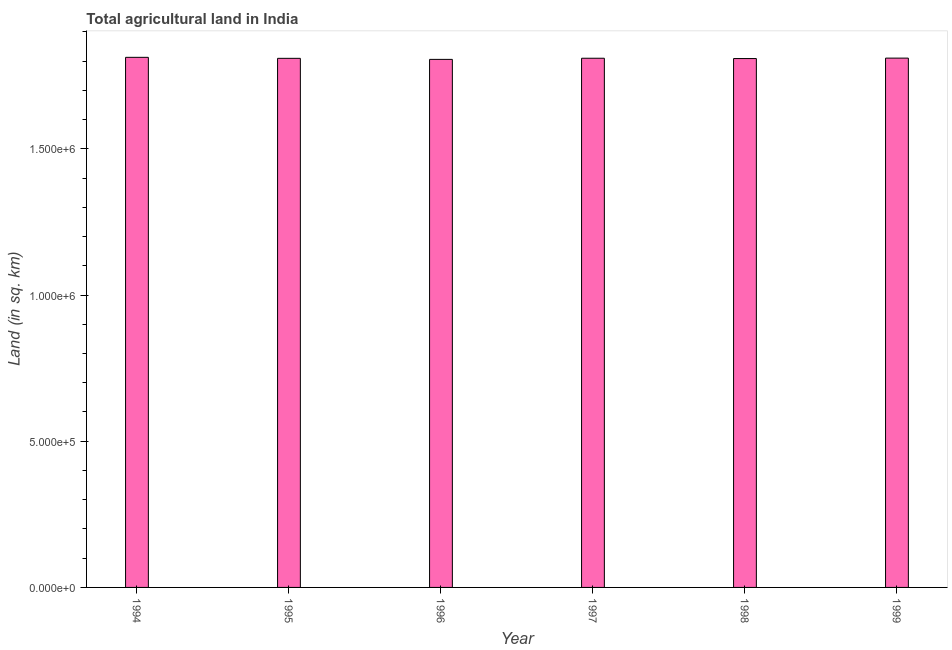Does the graph contain any zero values?
Your response must be concise. No. What is the title of the graph?
Provide a short and direct response. Total agricultural land in India. What is the label or title of the Y-axis?
Provide a succinct answer. Land (in sq. km). What is the agricultural land in 1998?
Provide a short and direct response. 1.81e+06. Across all years, what is the maximum agricultural land?
Your answer should be compact. 1.81e+06. Across all years, what is the minimum agricultural land?
Your answer should be compact. 1.81e+06. In which year was the agricultural land maximum?
Give a very brief answer. 1994. What is the sum of the agricultural land?
Your answer should be compact. 1.09e+07. What is the difference between the agricultural land in 1996 and 1999?
Provide a succinct answer. -4320. What is the average agricultural land per year?
Your answer should be very brief. 1.81e+06. What is the median agricultural land?
Offer a very short reply. 1.81e+06. In how many years, is the agricultural land greater than 400000 sq. km?
Provide a short and direct response. 6. What is the ratio of the agricultural land in 1997 to that in 1999?
Your answer should be very brief. 1. What is the difference between the highest and the second highest agricultural land?
Provide a succinct answer. 2700. What is the difference between the highest and the lowest agricultural land?
Provide a short and direct response. 7020. In how many years, is the agricultural land greater than the average agricultural land taken over all years?
Ensure brevity in your answer.  3. How many bars are there?
Offer a very short reply. 6. Are all the bars in the graph horizontal?
Provide a succinct answer. No. How many years are there in the graph?
Your response must be concise. 6. What is the difference between two consecutive major ticks on the Y-axis?
Offer a very short reply. 5.00e+05. What is the Land (in sq. km) in 1994?
Make the answer very short. 1.81e+06. What is the Land (in sq. km) in 1995?
Ensure brevity in your answer.  1.81e+06. What is the Land (in sq. km) in 1996?
Your answer should be compact. 1.81e+06. What is the Land (in sq. km) in 1997?
Make the answer very short. 1.81e+06. What is the Land (in sq. km) in 1998?
Give a very brief answer. 1.81e+06. What is the Land (in sq. km) in 1999?
Offer a very short reply. 1.81e+06. What is the difference between the Land (in sq. km) in 1994 and 1995?
Your answer should be compact. 3460. What is the difference between the Land (in sq. km) in 1994 and 1996?
Your answer should be compact. 7020. What is the difference between the Land (in sq. km) in 1994 and 1997?
Provide a succinct answer. 3100. What is the difference between the Land (in sq. km) in 1994 and 1998?
Give a very brief answer. 4170. What is the difference between the Land (in sq. km) in 1994 and 1999?
Make the answer very short. 2700. What is the difference between the Land (in sq. km) in 1995 and 1996?
Ensure brevity in your answer.  3560. What is the difference between the Land (in sq. km) in 1995 and 1997?
Ensure brevity in your answer.  -360. What is the difference between the Land (in sq. km) in 1995 and 1998?
Provide a succinct answer. 710. What is the difference between the Land (in sq. km) in 1995 and 1999?
Your response must be concise. -760. What is the difference between the Land (in sq. km) in 1996 and 1997?
Ensure brevity in your answer.  -3920. What is the difference between the Land (in sq. km) in 1996 and 1998?
Keep it short and to the point. -2850. What is the difference between the Land (in sq. km) in 1996 and 1999?
Your answer should be compact. -4320. What is the difference between the Land (in sq. km) in 1997 and 1998?
Your answer should be very brief. 1070. What is the difference between the Land (in sq. km) in 1997 and 1999?
Provide a succinct answer. -400. What is the difference between the Land (in sq. km) in 1998 and 1999?
Your answer should be very brief. -1470. What is the ratio of the Land (in sq. km) in 1994 to that in 1995?
Ensure brevity in your answer.  1. What is the ratio of the Land (in sq. km) in 1994 to that in 1996?
Provide a succinct answer. 1. What is the ratio of the Land (in sq. km) in 1994 to that in 1998?
Your answer should be compact. 1. What is the ratio of the Land (in sq. km) in 1995 to that in 1997?
Your answer should be very brief. 1. What is the ratio of the Land (in sq. km) in 1995 to that in 1998?
Your response must be concise. 1. What is the ratio of the Land (in sq. km) in 1995 to that in 1999?
Your response must be concise. 1. What is the ratio of the Land (in sq. km) in 1996 to that in 1998?
Give a very brief answer. 1. What is the ratio of the Land (in sq. km) in 1996 to that in 1999?
Give a very brief answer. 1. 